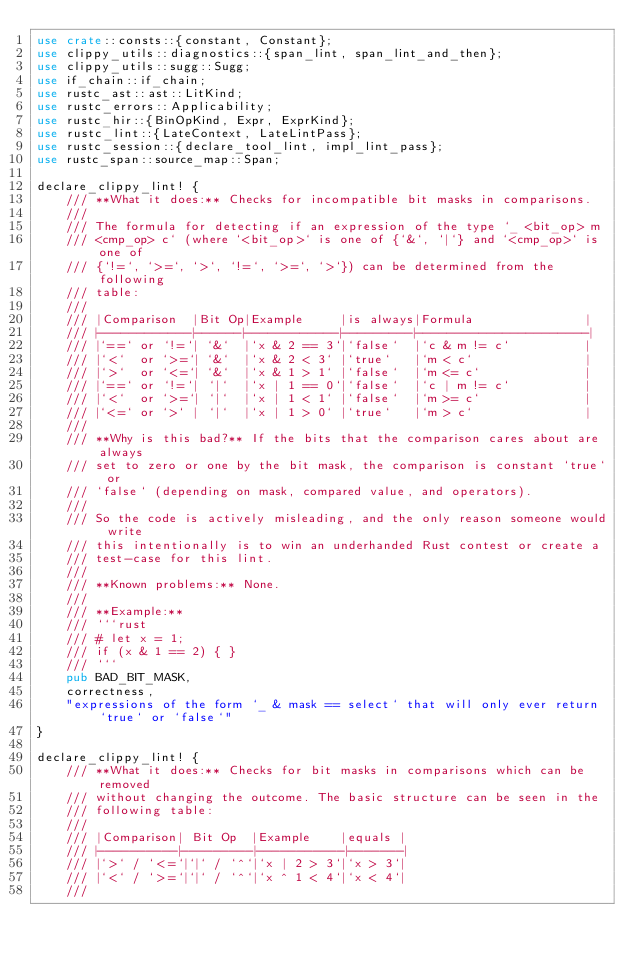<code> <loc_0><loc_0><loc_500><loc_500><_Rust_>use crate::consts::{constant, Constant};
use clippy_utils::diagnostics::{span_lint, span_lint_and_then};
use clippy_utils::sugg::Sugg;
use if_chain::if_chain;
use rustc_ast::ast::LitKind;
use rustc_errors::Applicability;
use rustc_hir::{BinOpKind, Expr, ExprKind};
use rustc_lint::{LateContext, LateLintPass};
use rustc_session::{declare_tool_lint, impl_lint_pass};
use rustc_span::source_map::Span;

declare_clippy_lint! {
    /// **What it does:** Checks for incompatible bit masks in comparisons.
    ///
    /// The formula for detecting if an expression of the type `_ <bit_op> m
    /// <cmp_op> c` (where `<bit_op>` is one of {`&`, `|`} and `<cmp_op>` is one of
    /// {`!=`, `>=`, `>`, `!=`, `>=`, `>`}) can be determined from the following
    /// table:
    ///
    /// |Comparison  |Bit Op|Example     |is always|Formula               |
    /// |------------|------|------------|---------|----------------------|
    /// |`==` or `!=`| `&`  |`x & 2 == 3`|`false`  |`c & m != c`          |
    /// |`<`  or `>=`| `&`  |`x & 2 < 3` |`true`   |`m < c`               |
    /// |`>`  or `<=`| `&`  |`x & 1 > 1` |`false`  |`m <= c`              |
    /// |`==` or `!=`| `|`  |`x | 1 == 0`|`false`  |`c | m != c`          |
    /// |`<`  or `>=`| `|`  |`x | 1 < 1` |`false`  |`m >= c`              |
    /// |`<=` or `>` | `|`  |`x | 1 > 0` |`true`   |`m > c`               |
    ///
    /// **Why is this bad?** If the bits that the comparison cares about are always
    /// set to zero or one by the bit mask, the comparison is constant `true` or
    /// `false` (depending on mask, compared value, and operators).
    ///
    /// So the code is actively misleading, and the only reason someone would write
    /// this intentionally is to win an underhanded Rust contest or create a
    /// test-case for this lint.
    ///
    /// **Known problems:** None.
    ///
    /// **Example:**
    /// ```rust
    /// # let x = 1;
    /// if (x & 1 == 2) { }
    /// ```
    pub BAD_BIT_MASK,
    correctness,
    "expressions of the form `_ & mask == select` that will only ever return `true` or `false`"
}

declare_clippy_lint! {
    /// **What it does:** Checks for bit masks in comparisons which can be removed
    /// without changing the outcome. The basic structure can be seen in the
    /// following table:
    ///
    /// |Comparison| Bit Op  |Example    |equals |
    /// |----------|---------|-----------|-------|
    /// |`>` / `<=`|`|` / `^`|`x | 2 > 3`|`x > 3`|
    /// |`<` / `>=`|`|` / `^`|`x ^ 1 < 4`|`x < 4`|
    ///</code> 